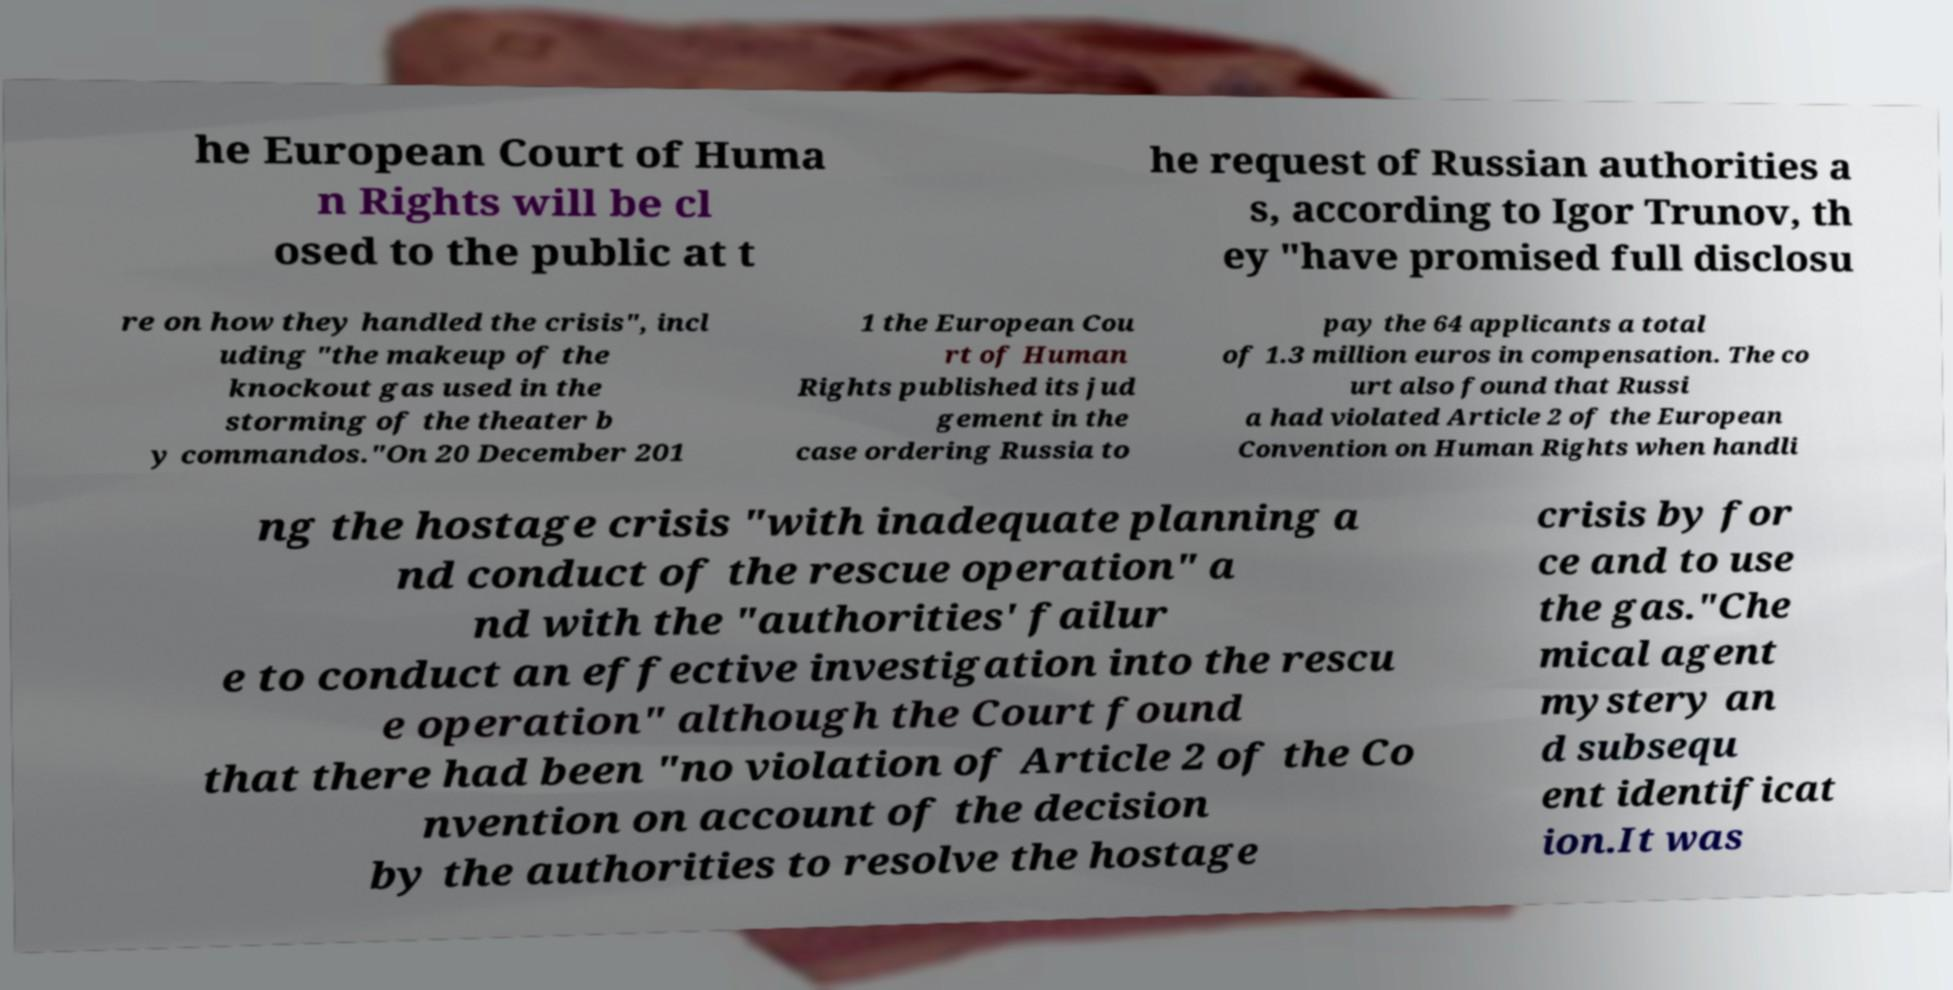Could you extract and type out the text from this image? he European Court of Huma n Rights will be cl osed to the public at t he request of Russian authorities a s, according to Igor Trunov, th ey "have promised full disclosu re on how they handled the crisis", incl uding "the makeup of the knockout gas used in the storming of the theater b y commandos."On 20 December 201 1 the European Cou rt of Human Rights published its jud gement in the case ordering Russia to pay the 64 applicants a total of 1.3 million euros in compensation. The co urt also found that Russi a had violated Article 2 of the European Convention on Human Rights when handli ng the hostage crisis "with inadequate planning a nd conduct of the rescue operation" a nd with the "authorities' failur e to conduct an effective investigation into the rescu e operation" although the Court found that there had been "no violation of Article 2 of the Co nvention on account of the decision by the authorities to resolve the hostage crisis by for ce and to use the gas."Che mical agent mystery an d subsequ ent identificat ion.It was 